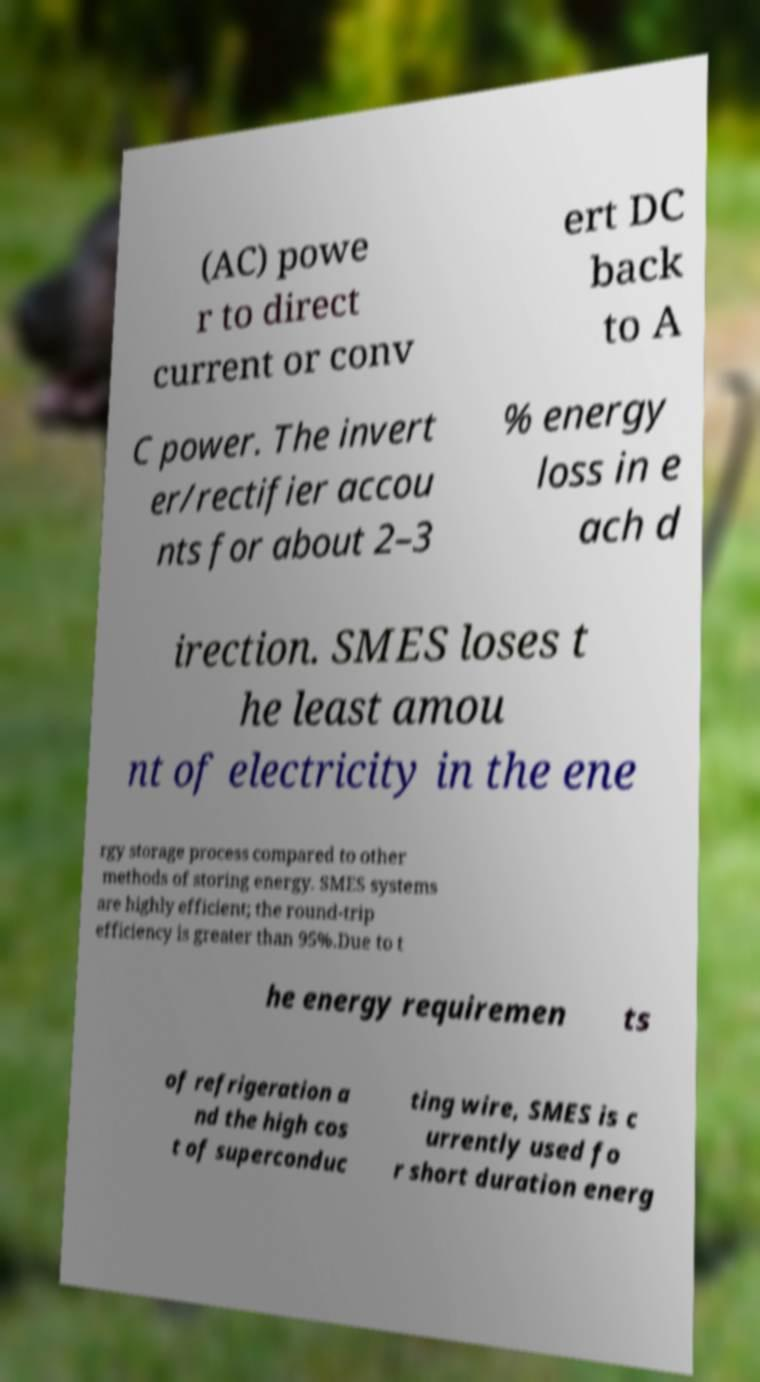Can you read and provide the text displayed in the image?This photo seems to have some interesting text. Can you extract and type it out for me? (AC) powe r to direct current or conv ert DC back to A C power. The invert er/rectifier accou nts for about 2–3 % energy loss in e ach d irection. SMES loses t he least amou nt of electricity in the ene rgy storage process compared to other methods of storing energy. SMES systems are highly efficient; the round-trip efficiency is greater than 95%.Due to t he energy requiremen ts of refrigeration a nd the high cos t of superconduc ting wire, SMES is c urrently used fo r short duration energ 